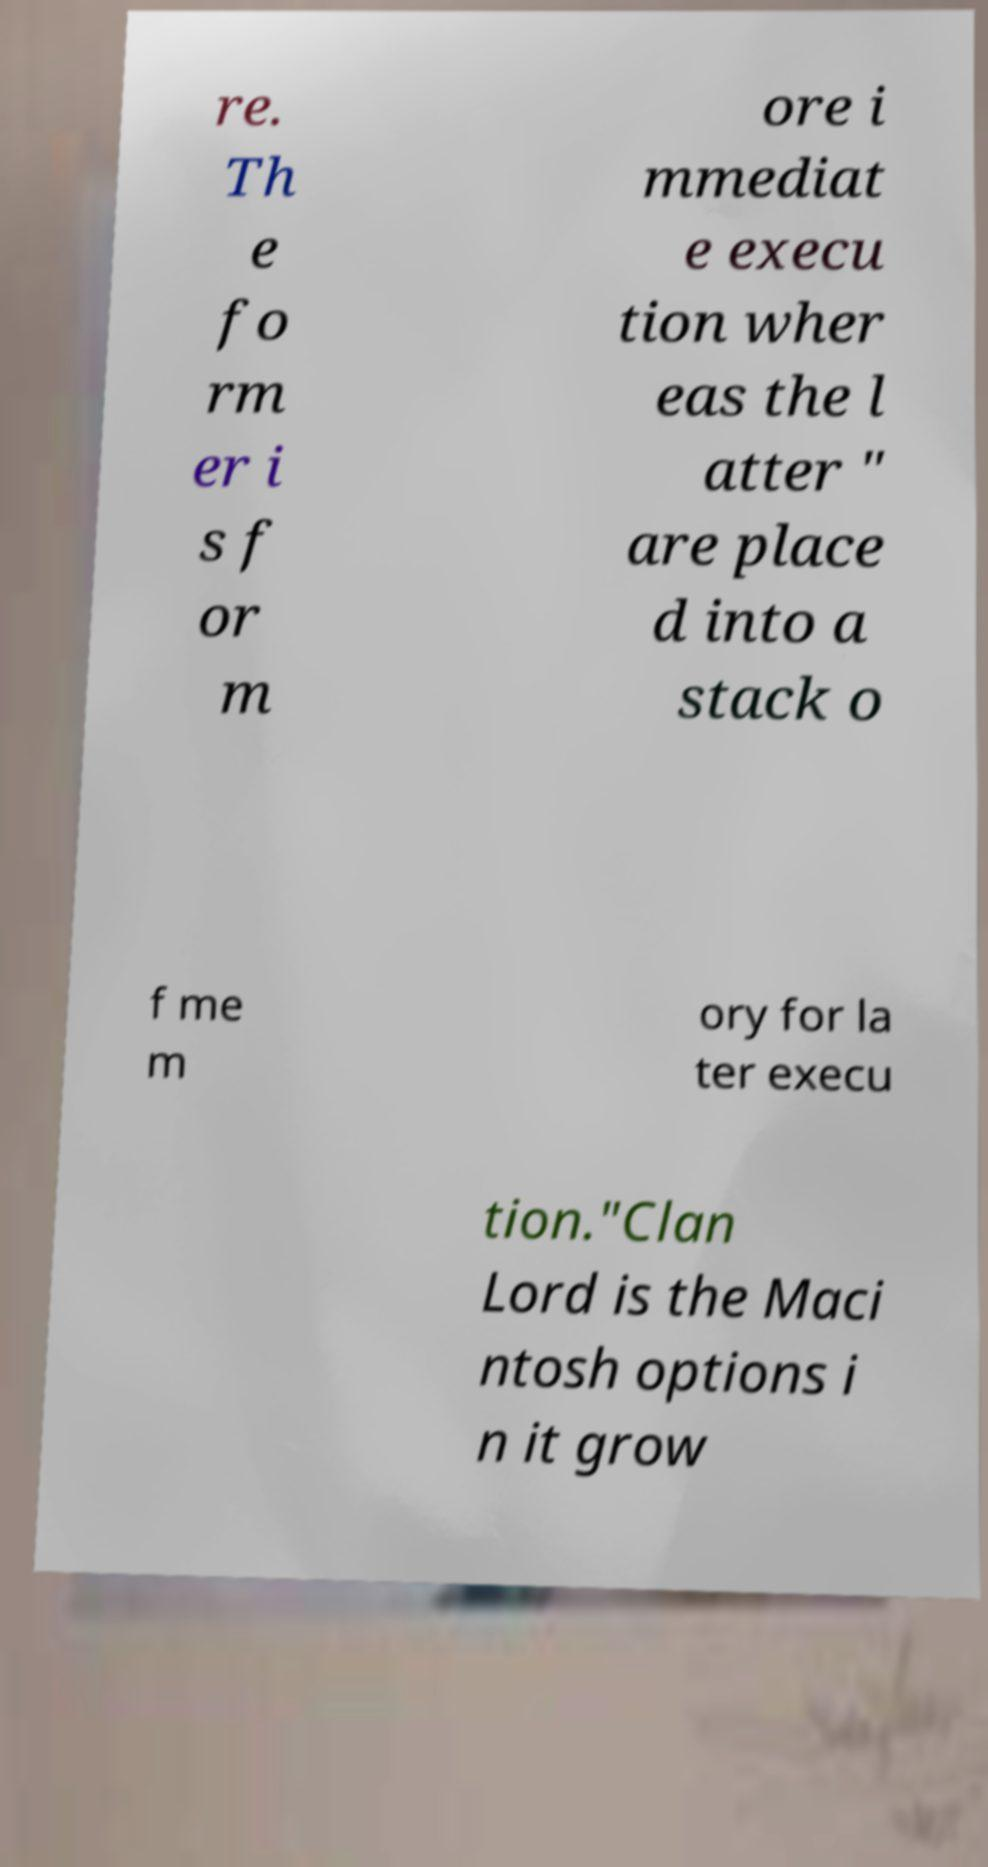Can you accurately transcribe the text from the provided image for me? re. Th e fo rm er i s f or m ore i mmediat e execu tion wher eas the l atter " are place d into a stack o f me m ory for la ter execu tion."Clan Lord is the Maci ntosh options i n it grow 